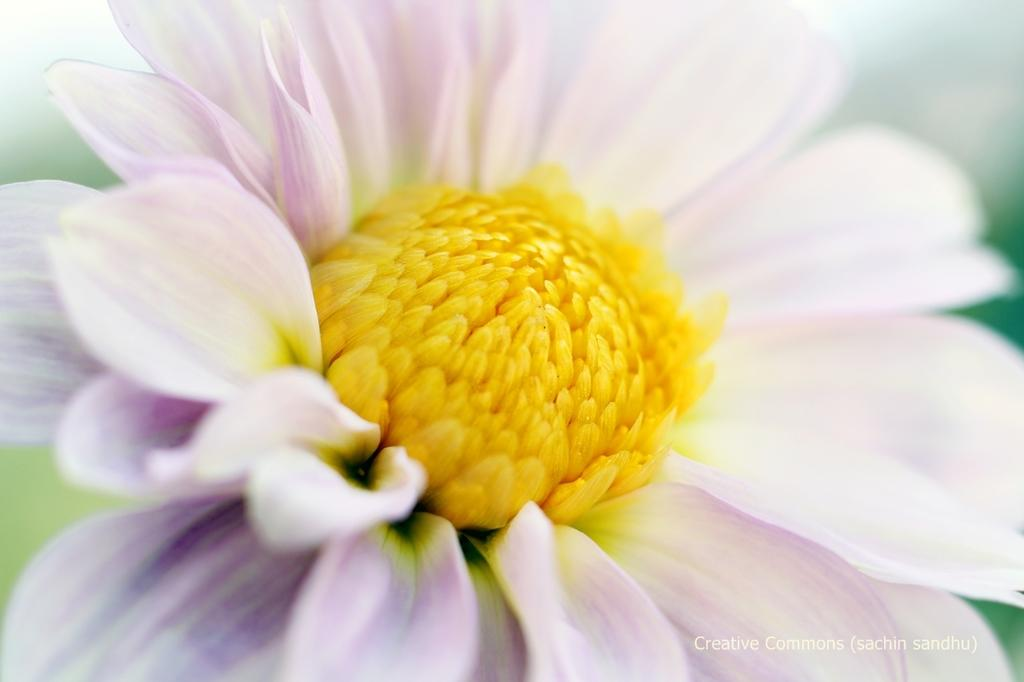What is the main subject of the image? There is a flower in the image. How would you describe the background of the image? The background of the image is blurred and green. Where is the text located in the image? The text is in the bottom right side of the image. What is the temperature downtown during the birth of the flower in the image? There is no information about the temperature, downtown, or the birth of the flower in the image. 